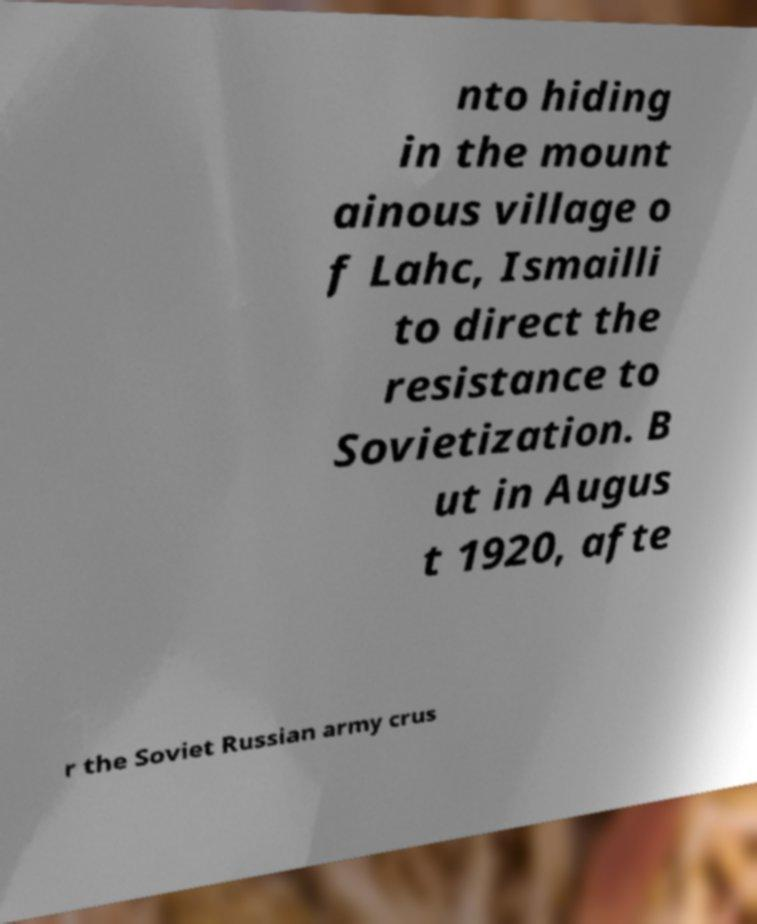I need the written content from this picture converted into text. Can you do that? nto hiding in the mount ainous village o f Lahc, Ismailli to direct the resistance to Sovietization. B ut in Augus t 1920, afte r the Soviet Russian army crus 